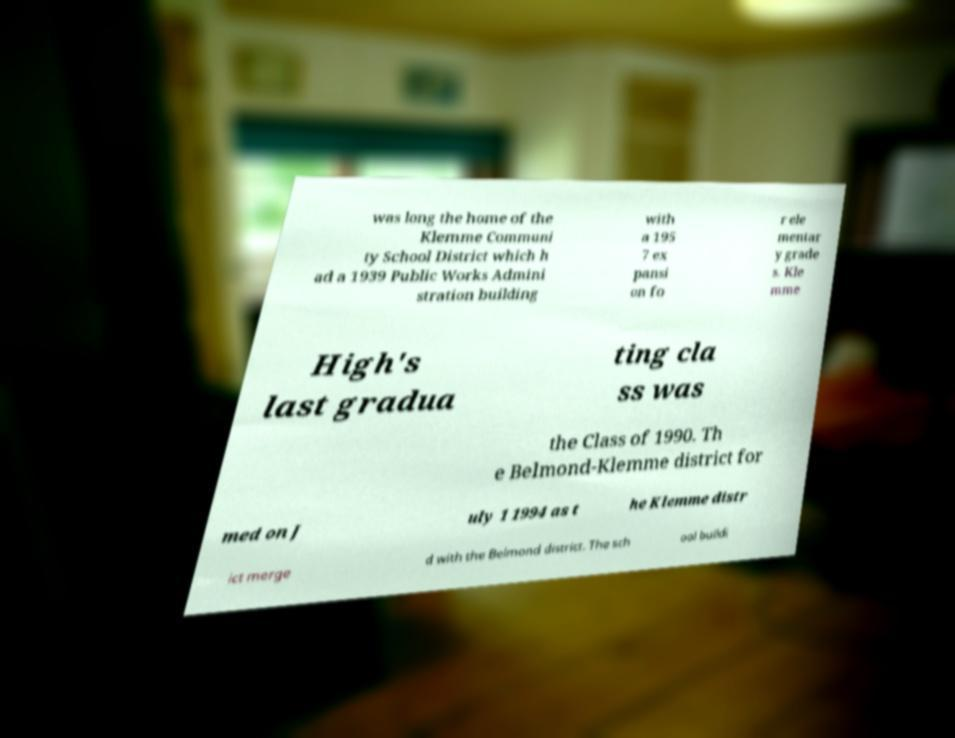Please identify and transcribe the text found in this image. was long the home of the Klemme Communi ty School District which h ad a 1939 Public Works Admini stration building with a 195 7 ex pansi on fo r ele mentar y grade s. Kle mme High's last gradua ting cla ss was the Class of 1990. Th e Belmond-Klemme district for med on J uly 1 1994 as t he Klemme distr ict merge d with the Belmond district. The sch ool buildi 